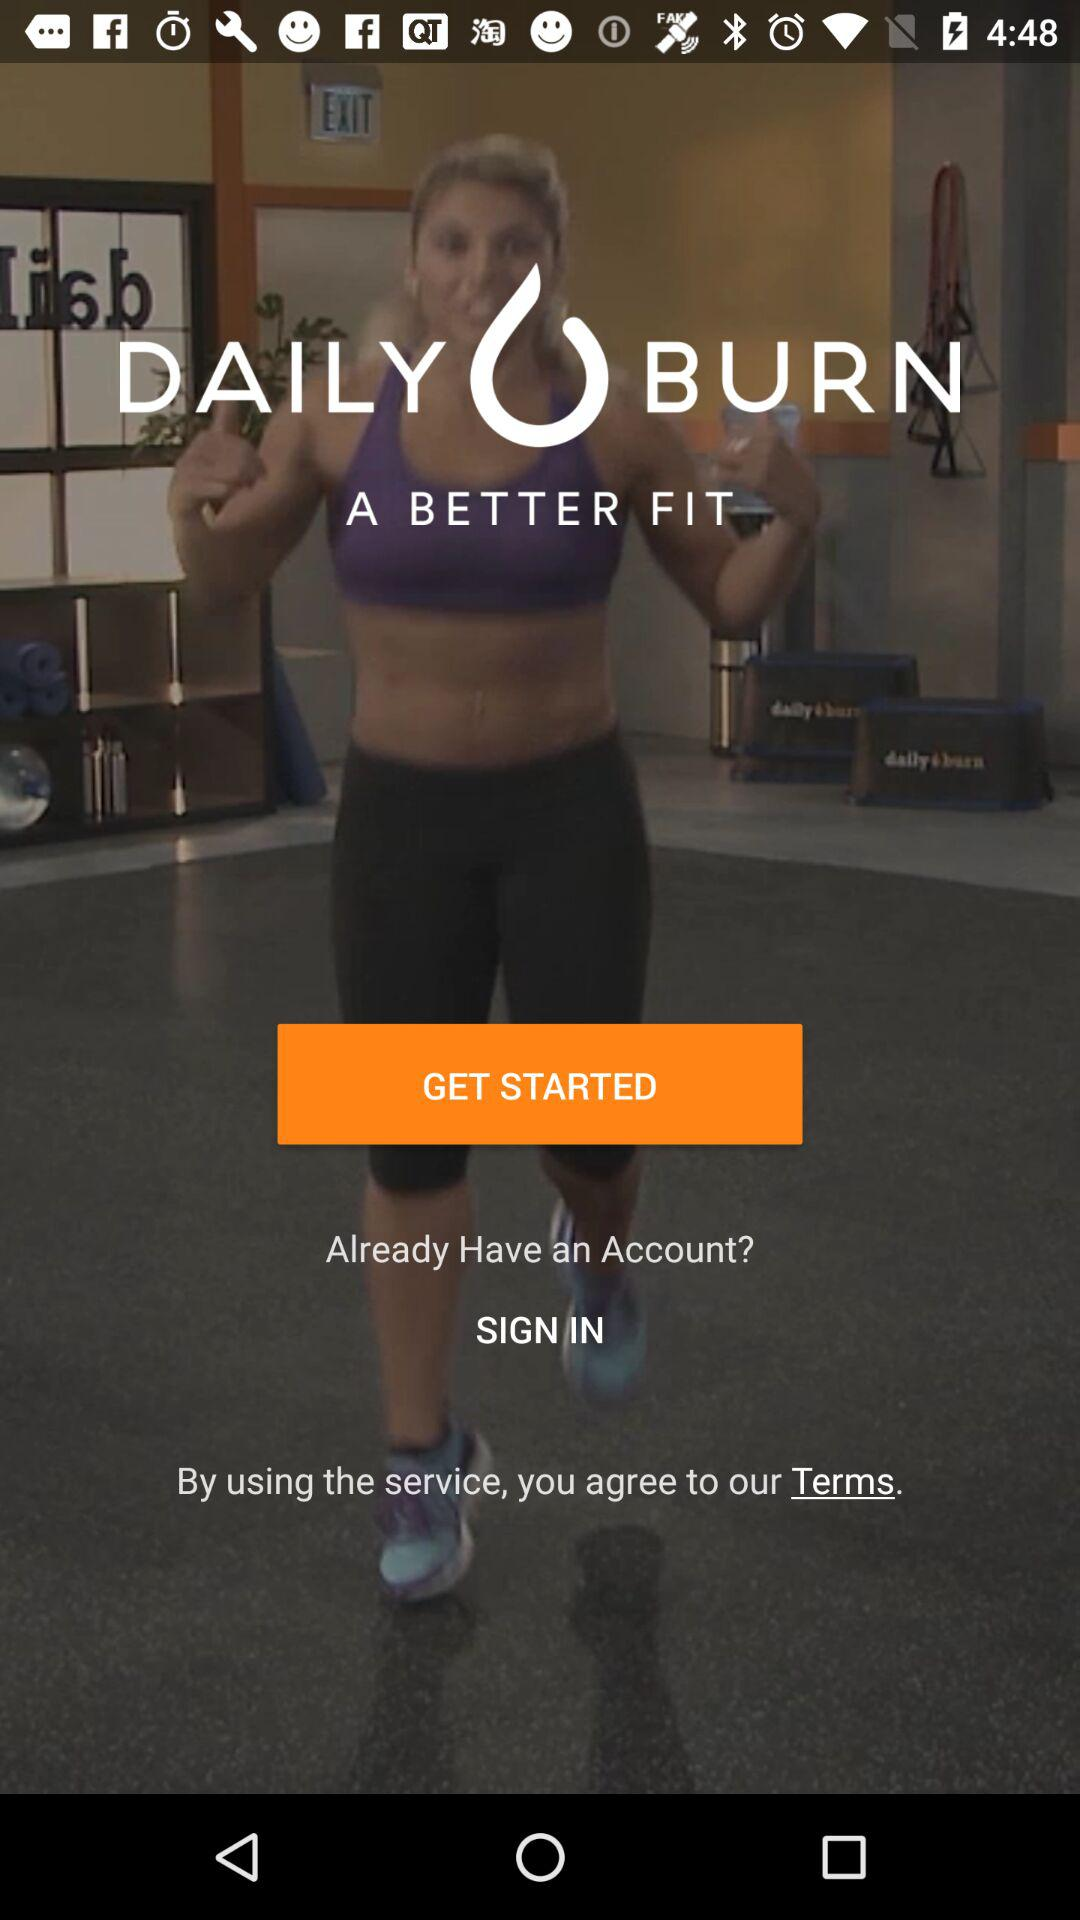What is the application name? The application name is "DAILY BURN". 